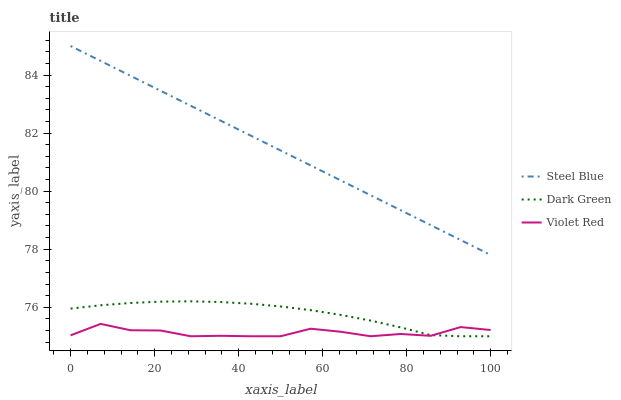Does Violet Red have the minimum area under the curve?
Answer yes or no. Yes. Does Steel Blue have the maximum area under the curve?
Answer yes or no. Yes. Does Dark Green have the minimum area under the curve?
Answer yes or no. No. Does Dark Green have the maximum area under the curve?
Answer yes or no. No. Is Steel Blue the smoothest?
Answer yes or no. Yes. Is Violet Red the roughest?
Answer yes or no. Yes. Is Dark Green the smoothest?
Answer yes or no. No. Is Dark Green the roughest?
Answer yes or no. No. Does Violet Red have the lowest value?
Answer yes or no. Yes. Does Steel Blue have the lowest value?
Answer yes or no. No. Does Steel Blue have the highest value?
Answer yes or no. Yes. Does Dark Green have the highest value?
Answer yes or no. No. Is Dark Green less than Steel Blue?
Answer yes or no. Yes. Is Steel Blue greater than Dark Green?
Answer yes or no. Yes. Does Dark Green intersect Violet Red?
Answer yes or no. Yes. Is Dark Green less than Violet Red?
Answer yes or no. No. Is Dark Green greater than Violet Red?
Answer yes or no. No. Does Dark Green intersect Steel Blue?
Answer yes or no. No. 